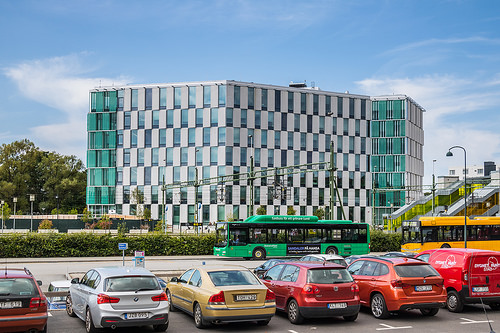<image>
Is the coke behind the road? No. The coke is not behind the road. From this viewpoint, the coke appears to be positioned elsewhere in the scene. 